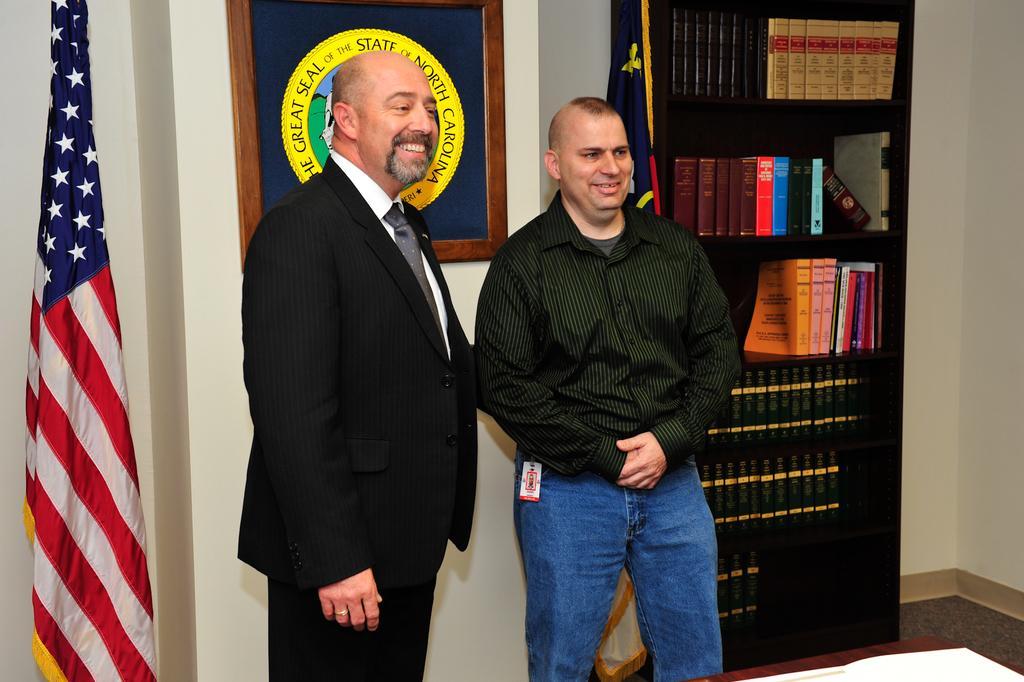How would you summarize this image in a sentence or two? In this image I can see two persons are standing on the floor. In the background I can see a cupboard in which books are there, flag and a wall on which a wall painting is there. This image is taken in a room. 